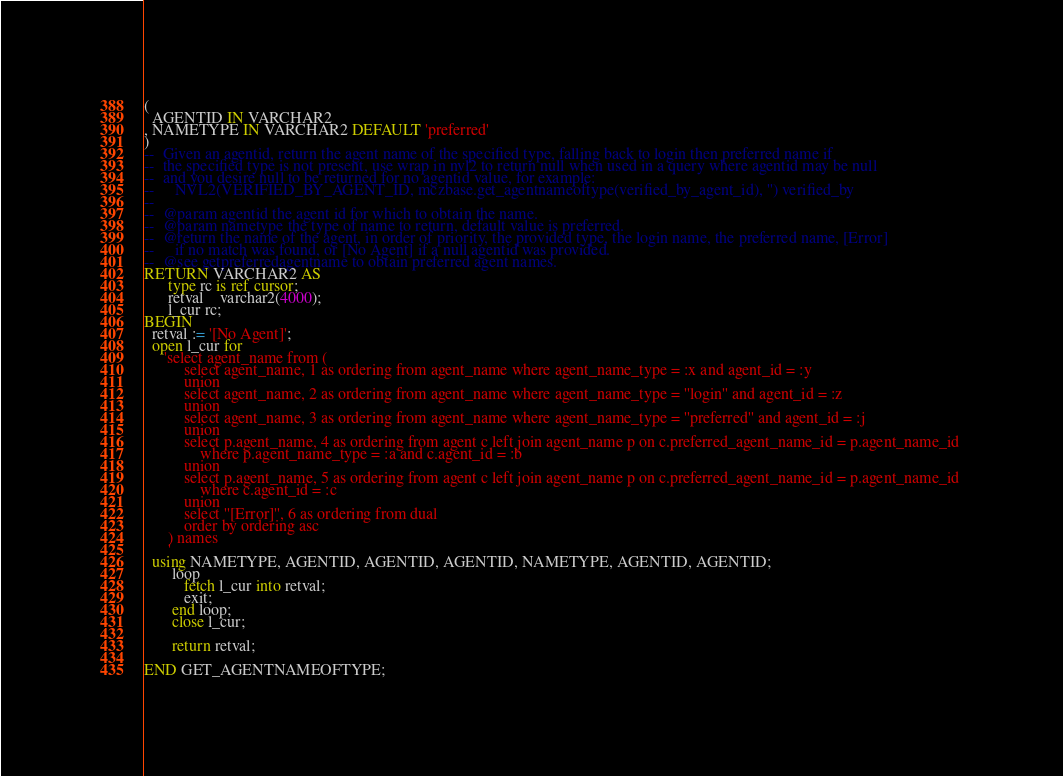Convert code to text. <code><loc_0><loc_0><loc_500><loc_500><_SQL_>(
  AGENTID IN VARCHAR2
, NAMETYPE IN VARCHAR2 DEFAULT 'preferred' 
) 
--  Given an agentid, return the agent name of the specified type, falling back to login then preferred name if 
--  the specified type is not present, use wrap in nvl2 to return null when used in a query where agentid may be null 
--  and you desire null to be returned for no agentid value, for example:
--     NVL2(VERIFIED_BY_AGENT_ID, mczbase.get_agentnameoftype(verified_by_agent_id), '') verified_by
--  
--  @param agentid the agent id for which to obtain the name.
--  @param nametype the type of name to return, default value is preferred.
--  @return the name of the agent, in order of priority, the provided type, the login name, the preferred name, [Error] 
--     if no match was found, or [No Agent] if a null agentid was provided.
--  @see getpreferredagentname to obtain preferred agent names.
RETURN VARCHAR2 AS 
      type rc is ref cursor;
      retval    varchar2(4000);
      l_cur rc;
BEGIN
  retval := '[No Agent]';
  open l_cur for 
     'select agent_name from (
          select agent_name, 1 as ordering from agent_name where agent_name_type = :x and agent_id = :y
          union 
          select agent_name, 2 as ordering from agent_name where agent_name_type = ''login'' and agent_id = :z
          union 
          select agent_name, 3 as ordering from agent_name where agent_name_type = ''preferred'' and agent_id = :j
          union 
          select p.agent_name, 4 as ordering from agent c left join agent_name p on c.preferred_agent_name_id = p.agent_name_id 
              where p.agent_name_type = :a and c.agent_id = :b
          union 
          select p.agent_name, 5 as ordering from agent c left join agent_name p on c.preferred_agent_name_id = p.agent_name_id 
              where c.agent_id = :c              
          union 
          select ''[Error]'', 6 as ordering from dual 
          order by ordering asc
      ) names
      '
  using NAMETYPE, AGENTID, AGENTID, AGENTID, NAMETYPE, AGENTID, AGENTID; 
       loop 
          fetch l_cur into retval;
          exit;
       end loop;   
       close l_cur;

       return retval;
  
END GET_AGENTNAMEOFTYPE;</code> 